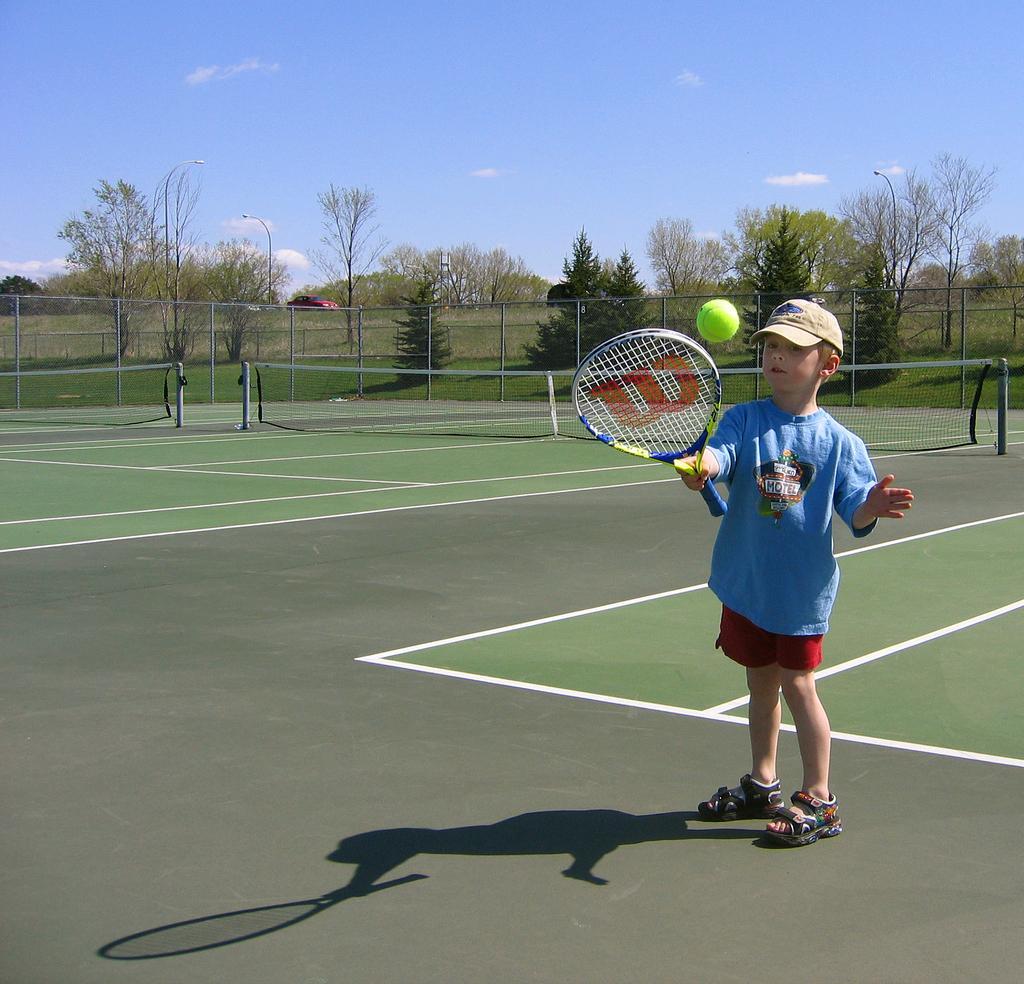How would you summarize this image in a sentence or two? In the picture we can see a tennis court with a green color surface and a boy standing and holding a tennis racket and hitting the ball, he is wearing a T-shirt, and a cap and in the background we can see a fencing and behind it we can see a grass surface and on it we can see trees and behind it we can see a car which is red in color and behind it we can see a pole with a light and behind it we can see a sky with clouds. 